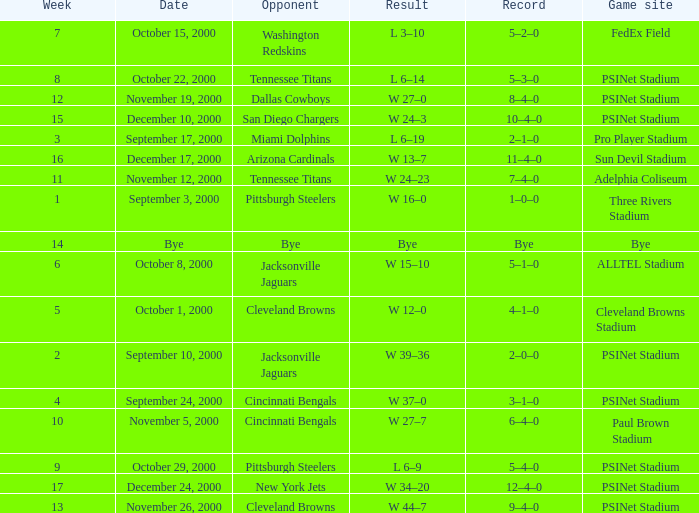Parse the table in full. {'header': ['Week', 'Date', 'Opponent', 'Result', 'Record', 'Game site'], 'rows': [['7', 'October 15, 2000', 'Washington Redskins', 'L 3–10', '5–2–0', 'FedEx Field'], ['8', 'October 22, 2000', 'Tennessee Titans', 'L 6–14', '5–3–0', 'PSINet Stadium'], ['12', 'November 19, 2000', 'Dallas Cowboys', 'W 27–0', '8–4–0', 'PSINet Stadium'], ['15', 'December 10, 2000', 'San Diego Chargers', 'W 24–3', '10–4–0', 'PSINet Stadium'], ['3', 'September 17, 2000', 'Miami Dolphins', 'L 6–19', '2–1–0', 'Pro Player Stadium'], ['16', 'December 17, 2000', 'Arizona Cardinals', 'W 13–7', '11–4–0', 'Sun Devil Stadium'], ['11', 'November 12, 2000', 'Tennessee Titans', 'W 24–23', '7–4–0', 'Adelphia Coliseum'], ['1', 'September 3, 2000', 'Pittsburgh Steelers', 'W 16–0', '1–0–0', 'Three Rivers Stadium'], ['14', 'Bye', 'Bye', 'Bye', 'Bye', 'Bye'], ['6', 'October 8, 2000', 'Jacksonville Jaguars', 'W 15–10', '5–1–0', 'ALLTEL Stadium'], ['5', 'October 1, 2000', 'Cleveland Browns', 'W 12–0', '4–1–0', 'Cleveland Browns Stadium'], ['2', 'September 10, 2000', 'Jacksonville Jaguars', 'W 39–36', '2–0–0', 'PSINet Stadium'], ['4', 'September 24, 2000', 'Cincinnati Bengals', 'W 37–0', '3–1–0', 'PSINet Stadium'], ['10', 'November 5, 2000', 'Cincinnati Bengals', 'W 27–7', '6–4–0', 'Paul Brown Stadium'], ['9', 'October 29, 2000', 'Pittsburgh Steelers', 'L 6–9', '5–4–0', 'PSINet Stadium'], ['17', 'December 24, 2000', 'New York Jets', 'W 34–20', '12–4–0', 'PSINet Stadium'], ['13', 'November 26, 2000', 'Cleveland Browns', 'W 44–7', '9–4–0', 'PSINet Stadium']]} What's the record after week 16? 12–4–0. 